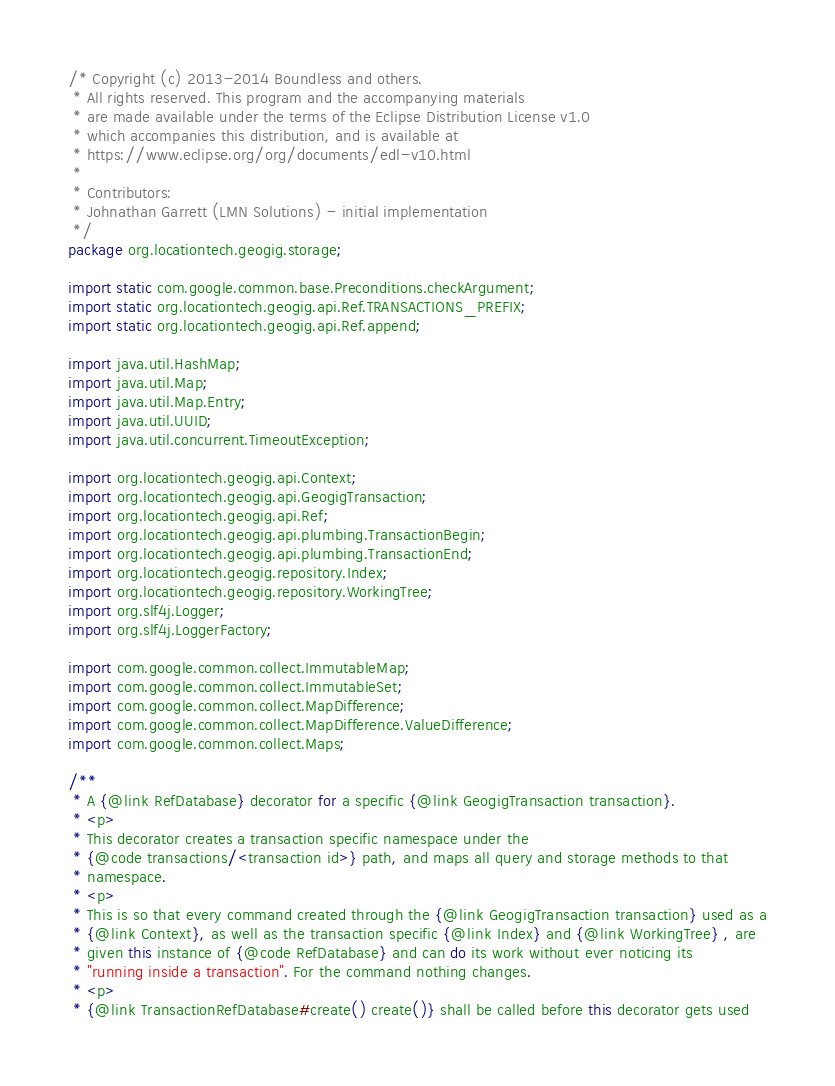Convert code to text. <code><loc_0><loc_0><loc_500><loc_500><_Java_>/* Copyright (c) 2013-2014 Boundless and others.
 * All rights reserved. This program and the accompanying materials
 * are made available under the terms of the Eclipse Distribution License v1.0
 * which accompanies this distribution, and is available at
 * https://www.eclipse.org/org/documents/edl-v10.html
 *
 * Contributors:
 * Johnathan Garrett (LMN Solutions) - initial implementation
 */
package org.locationtech.geogig.storage;

import static com.google.common.base.Preconditions.checkArgument;
import static org.locationtech.geogig.api.Ref.TRANSACTIONS_PREFIX;
import static org.locationtech.geogig.api.Ref.append;

import java.util.HashMap;
import java.util.Map;
import java.util.Map.Entry;
import java.util.UUID;
import java.util.concurrent.TimeoutException;

import org.locationtech.geogig.api.Context;
import org.locationtech.geogig.api.GeogigTransaction;
import org.locationtech.geogig.api.Ref;
import org.locationtech.geogig.api.plumbing.TransactionBegin;
import org.locationtech.geogig.api.plumbing.TransactionEnd;
import org.locationtech.geogig.repository.Index;
import org.locationtech.geogig.repository.WorkingTree;
import org.slf4j.Logger;
import org.slf4j.LoggerFactory;

import com.google.common.collect.ImmutableMap;
import com.google.common.collect.ImmutableSet;
import com.google.common.collect.MapDifference;
import com.google.common.collect.MapDifference.ValueDifference;
import com.google.common.collect.Maps;

/**
 * A {@link RefDatabase} decorator for a specific {@link GeogigTransaction transaction}.
 * <p>
 * This decorator creates a transaction specific namespace under the
 * {@code transactions/<transaction id>} path, and maps all query and storage methods to that
 * namespace.
 * <p>
 * This is so that every command created through the {@link GeogigTransaction transaction} used as a
 * {@link Context}, as well as the transaction specific {@link Index} and {@link WorkingTree} , are
 * given this instance of {@code RefDatabase} and can do its work without ever noticing its
 * "running inside a transaction". For the command nothing changes.
 * <p>
 * {@link TransactionRefDatabase#create() create()} shall be called before this decorator gets used</code> 